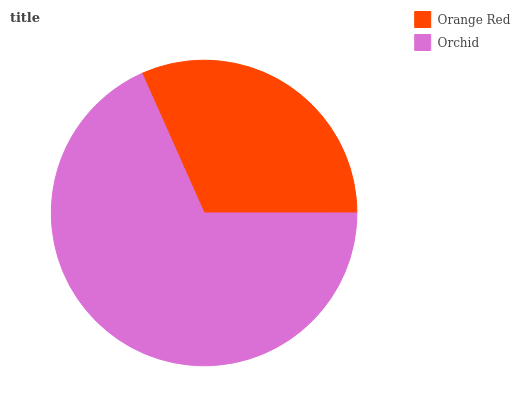Is Orange Red the minimum?
Answer yes or no. Yes. Is Orchid the maximum?
Answer yes or no. Yes. Is Orchid the minimum?
Answer yes or no. No. Is Orchid greater than Orange Red?
Answer yes or no. Yes. Is Orange Red less than Orchid?
Answer yes or no. Yes. Is Orange Red greater than Orchid?
Answer yes or no. No. Is Orchid less than Orange Red?
Answer yes or no. No. Is Orchid the high median?
Answer yes or no. Yes. Is Orange Red the low median?
Answer yes or no. Yes. Is Orange Red the high median?
Answer yes or no. No. Is Orchid the low median?
Answer yes or no. No. 